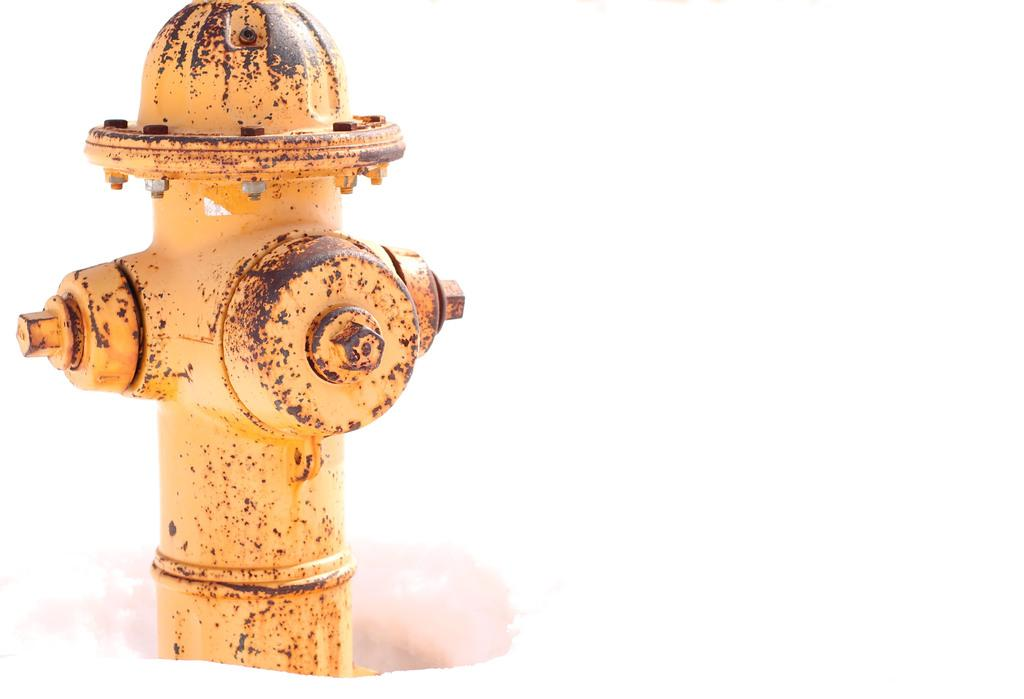What color is the fire hydrant in the image? The fire hydrant in the image is yellow. Where is the fire hydrant located in the image? The fire hydrant is in the snow. What type of silk material is draped over the fire hydrant in the image? There is no silk material present in the image; it only features a yellow fire hydrant in the snow. 